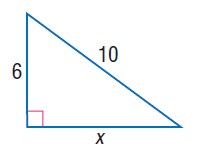Answer the mathemtical geometry problem and directly provide the correct option letter.
Question: Find x.
Choices: A: 6 B: 8 C: 10 D: 2 \sqrt { 34 } B 